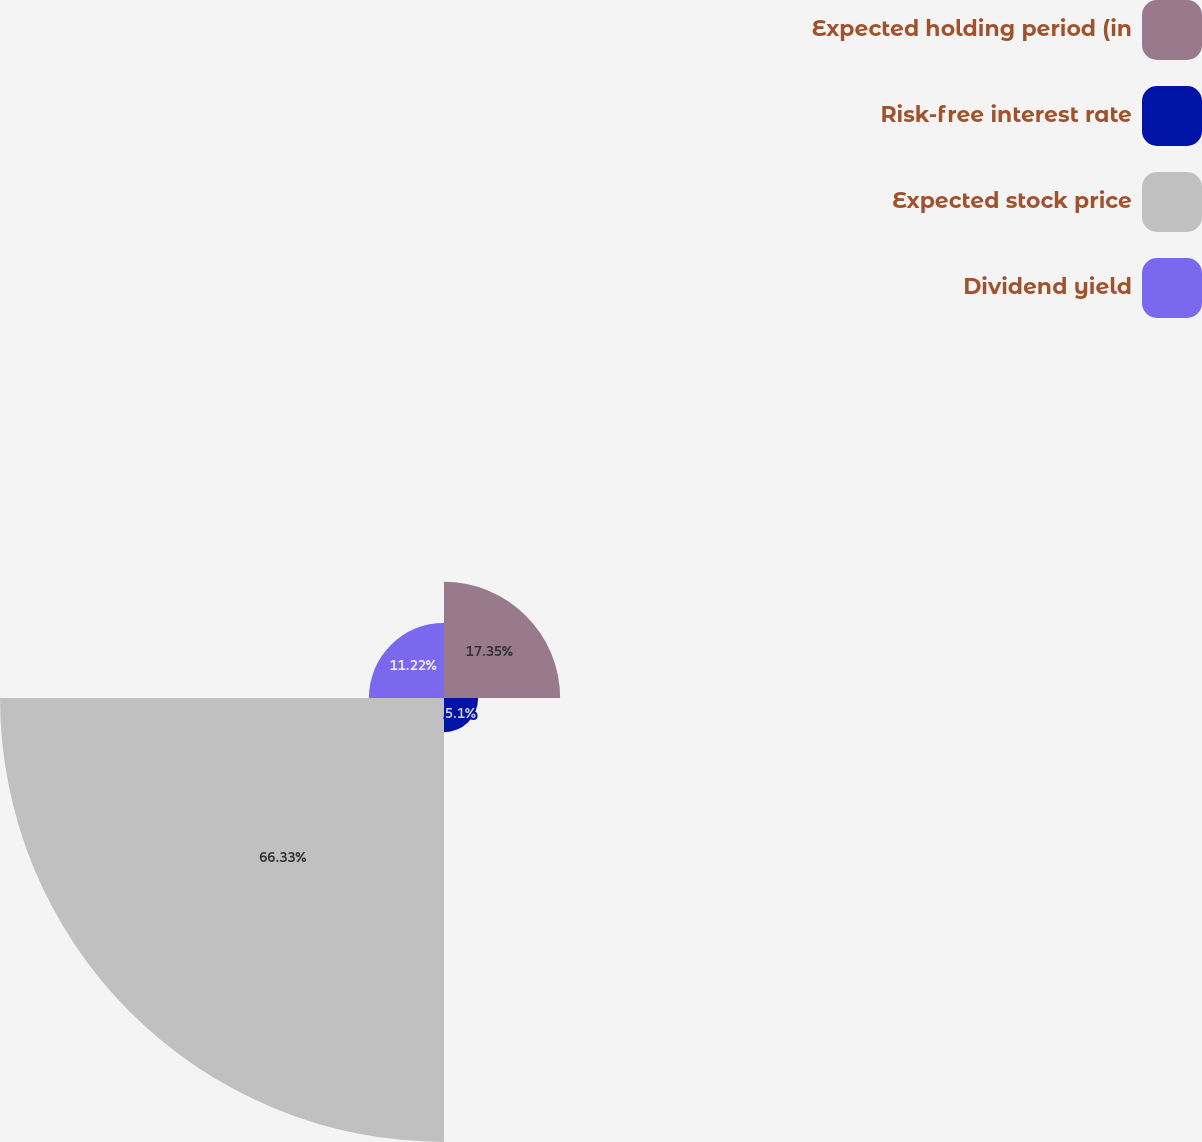<chart> <loc_0><loc_0><loc_500><loc_500><pie_chart><fcel>Expected holding period (in<fcel>Risk-free interest rate<fcel>Expected stock price<fcel>Dividend yield<nl><fcel>17.35%<fcel>5.1%<fcel>66.33%<fcel>11.22%<nl></chart> 